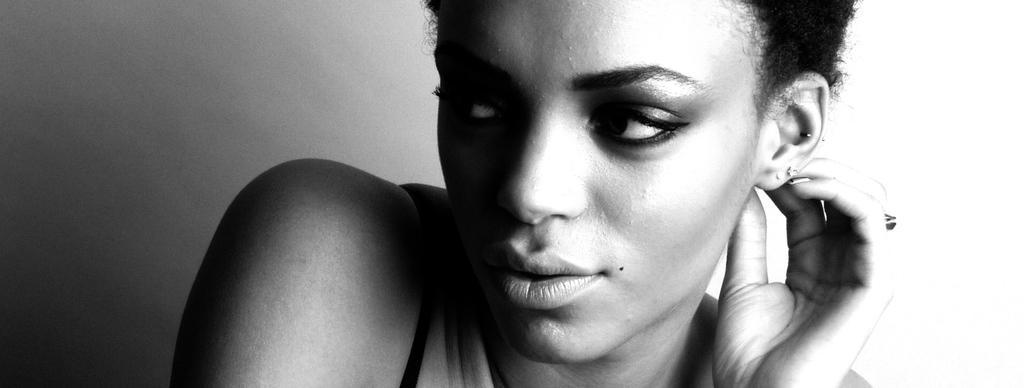In one or two sentences, can you explain what this image depicts? In this picture there is a woman. In the background of the image it is white and grey color. 